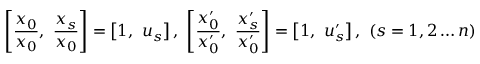Convert formula to latex. <formula><loc_0><loc_0><loc_500><loc_500>\left [ { \frac { x _ { 0 } } { x _ { 0 } } } , \ { \frac { x _ { s } } { x _ { 0 } } } \right ] = \left [ 1 , \ u _ { s } \right ] , \ \left [ { \frac { x _ { 0 } ^ { \prime } } { x _ { 0 } ^ { \prime } } } , \ { \frac { x _ { s } ^ { \prime } } { x _ { 0 } ^ { \prime } } } \right ] = \left [ 1 , \ u _ { s } ^ { \prime } \right ] , \ ( s = 1 , 2 \dots n )</formula> 